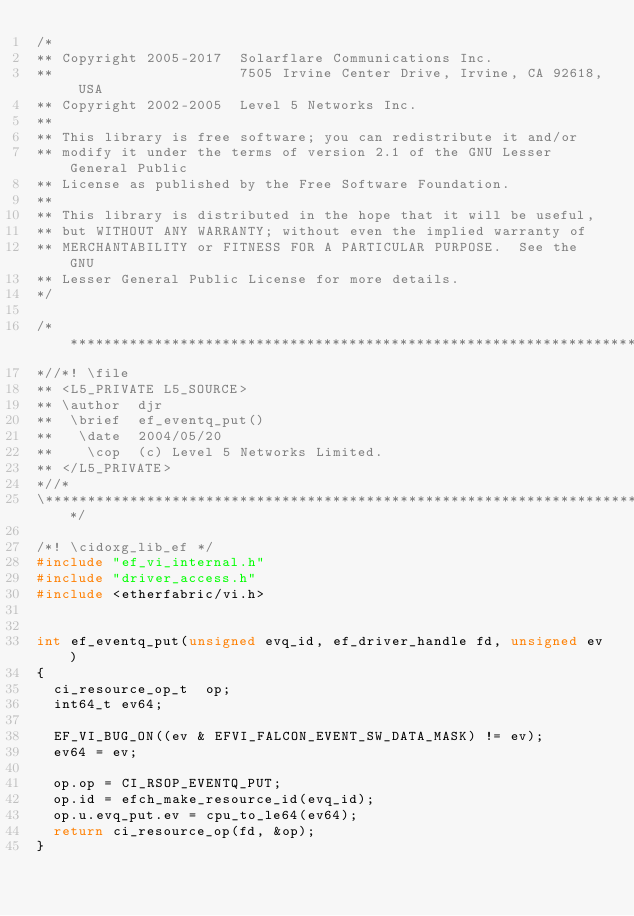<code> <loc_0><loc_0><loc_500><loc_500><_C_>/*
** Copyright 2005-2017  Solarflare Communications Inc.
**                      7505 Irvine Center Drive, Irvine, CA 92618, USA
** Copyright 2002-2005  Level 5 Networks Inc.
**
** This library is free software; you can redistribute it and/or
** modify it under the terms of version 2.1 of the GNU Lesser General Public
** License as published by the Free Software Foundation.
**
** This library is distributed in the hope that it will be useful,
** but WITHOUT ANY WARRANTY; without even the implied warranty of
** MERCHANTABILITY or FITNESS FOR A PARTICULAR PURPOSE.  See the GNU
** Lesser General Public License for more details.
*/

/**************************************************************************\
*//*! \file
** <L5_PRIVATE L5_SOURCE>
** \author  djr
**  \brief  ef_eventq_put()
**   \date  2004/05/20
**    \cop  (c) Level 5 Networks Limited.
** </L5_PRIVATE>
*//*
\**************************************************************************/

/*! \cidoxg_lib_ef */
#include "ef_vi_internal.h"
#include "driver_access.h"
#include <etherfabric/vi.h>


int ef_eventq_put(unsigned evq_id, ef_driver_handle fd, unsigned ev)
{
  ci_resource_op_t  op;
  int64_t ev64;

  EF_VI_BUG_ON((ev & EFVI_FALCON_EVENT_SW_DATA_MASK) != ev);
  ev64 = ev;

  op.op = CI_RSOP_EVENTQ_PUT;
  op.id = efch_make_resource_id(evq_id);
  op.u.evq_put.ev = cpu_to_le64(ev64);
  return ci_resource_op(fd, &op);
}
</code> 